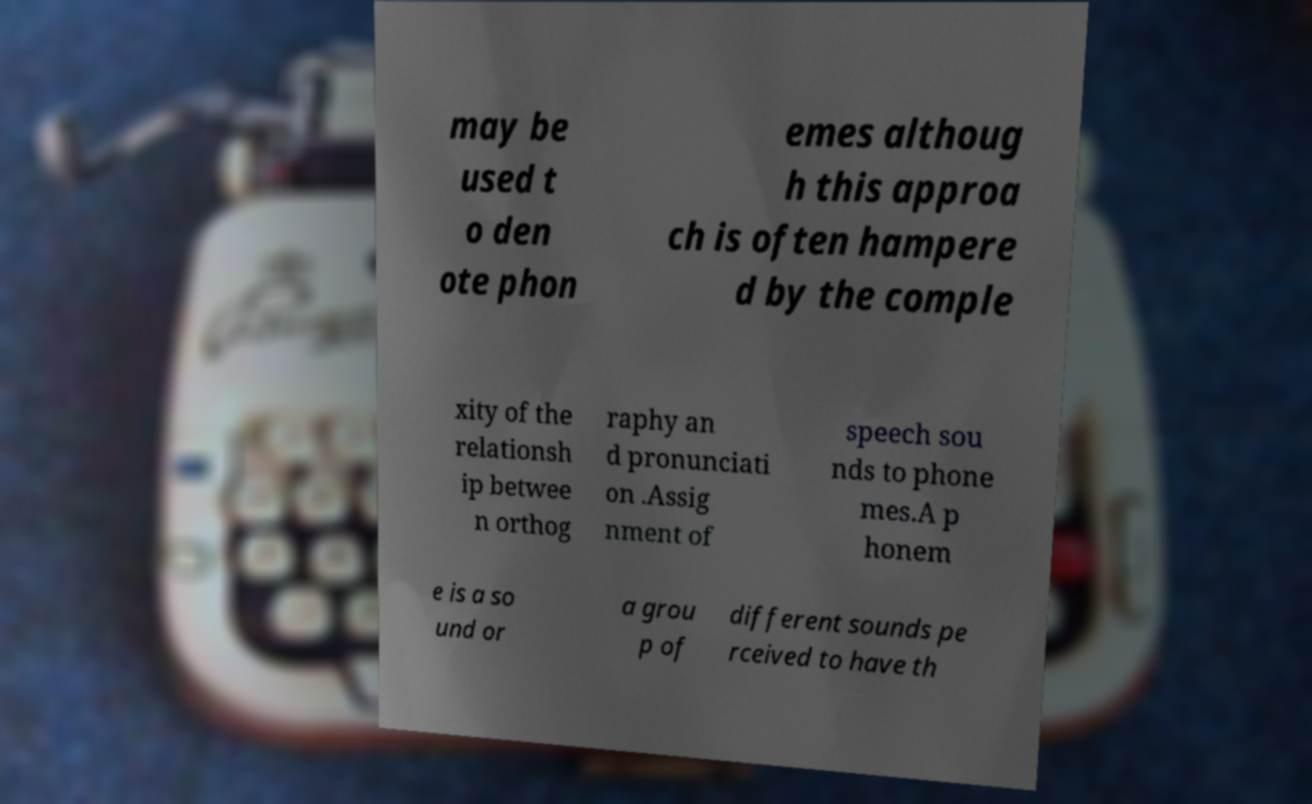Can you read and provide the text displayed in the image?This photo seems to have some interesting text. Can you extract and type it out for me? may be used t o den ote phon emes althoug h this approa ch is often hampere d by the comple xity of the relationsh ip betwee n orthog raphy an d pronunciati on .Assig nment of speech sou nds to phone mes.A p honem e is a so und or a grou p of different sounds pe rceived to have th 